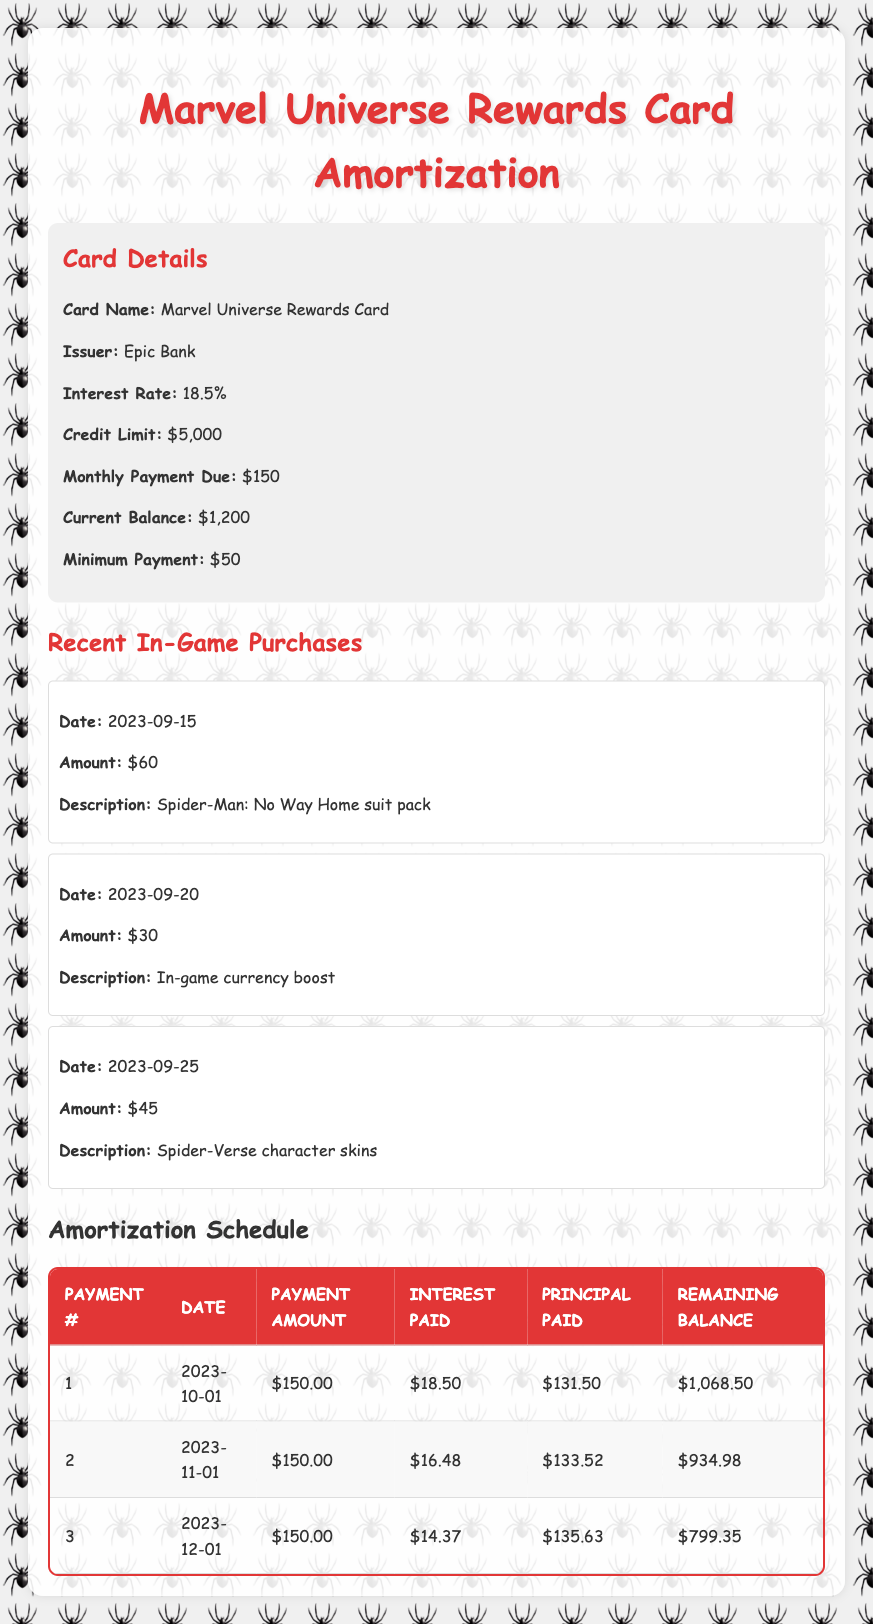What is the total amount of interest paid after the first three payments? The interest paid for each of the three payments in the table is as follows: first payment $18.50, second payment $16.48, and third payment $14.37. Summing these values gives $18.50 + $16.48 + $14.37 = $49.35.
Answer: $49.35 What is the remaining balance after the second payment? According to the table, after the second payment, the remaining balance is listed as $934.98.
Answer: $934.98 Did the monthly payment amount stay the same across all payments? The monthly payment amount is consistently shown as $150.00 for all three payments, indicating it did not change.
Answer: Yes How much total principal was paid after the three payments? The principal paid for each payment is $131.50, $133.52, and $135.63, respectively. Adding these values gives $131.50 + $133.52 + $135.63 = $400.65 as the total principal paid after three payments.
Answer: $400.65 What was the principal paid in the first payment? The principal paid in the first payment is clearly stated as $131.50 in the table.
Answer: $131.50 Is the remaining balance after the third payment lower than after the second payment? After the second payment, the remaining balance is $934.98, and after the third payment, it is $799.35. Since $799.35 is less than $934.98, the remaining balance has decreased.
Answer: Yes What is the average amount of interest paid across the first three payments? Adding the interest amounts from the first three payments gives $18.50 + $16.48 + $14.37 = $49.35. The average is then $49.35 divided by 3, which equals approximately $16.45.
Answer: $16.45 How much total was spent on in-game purchases mentioned in the table? The total of the in-game purchases is $60 + $30 + $45 = $135, thus the total amount spent on these in-game items is $135.
Answer: $135 Is the principal paid in the second payment greater than the interest paid in that payment? The principal paid in the second payment is $133.52 and the interest paid in that payment is $16.48. Since $133.52 is greater than $16.48, the principal is greater than the interest.
Answer: Yes 